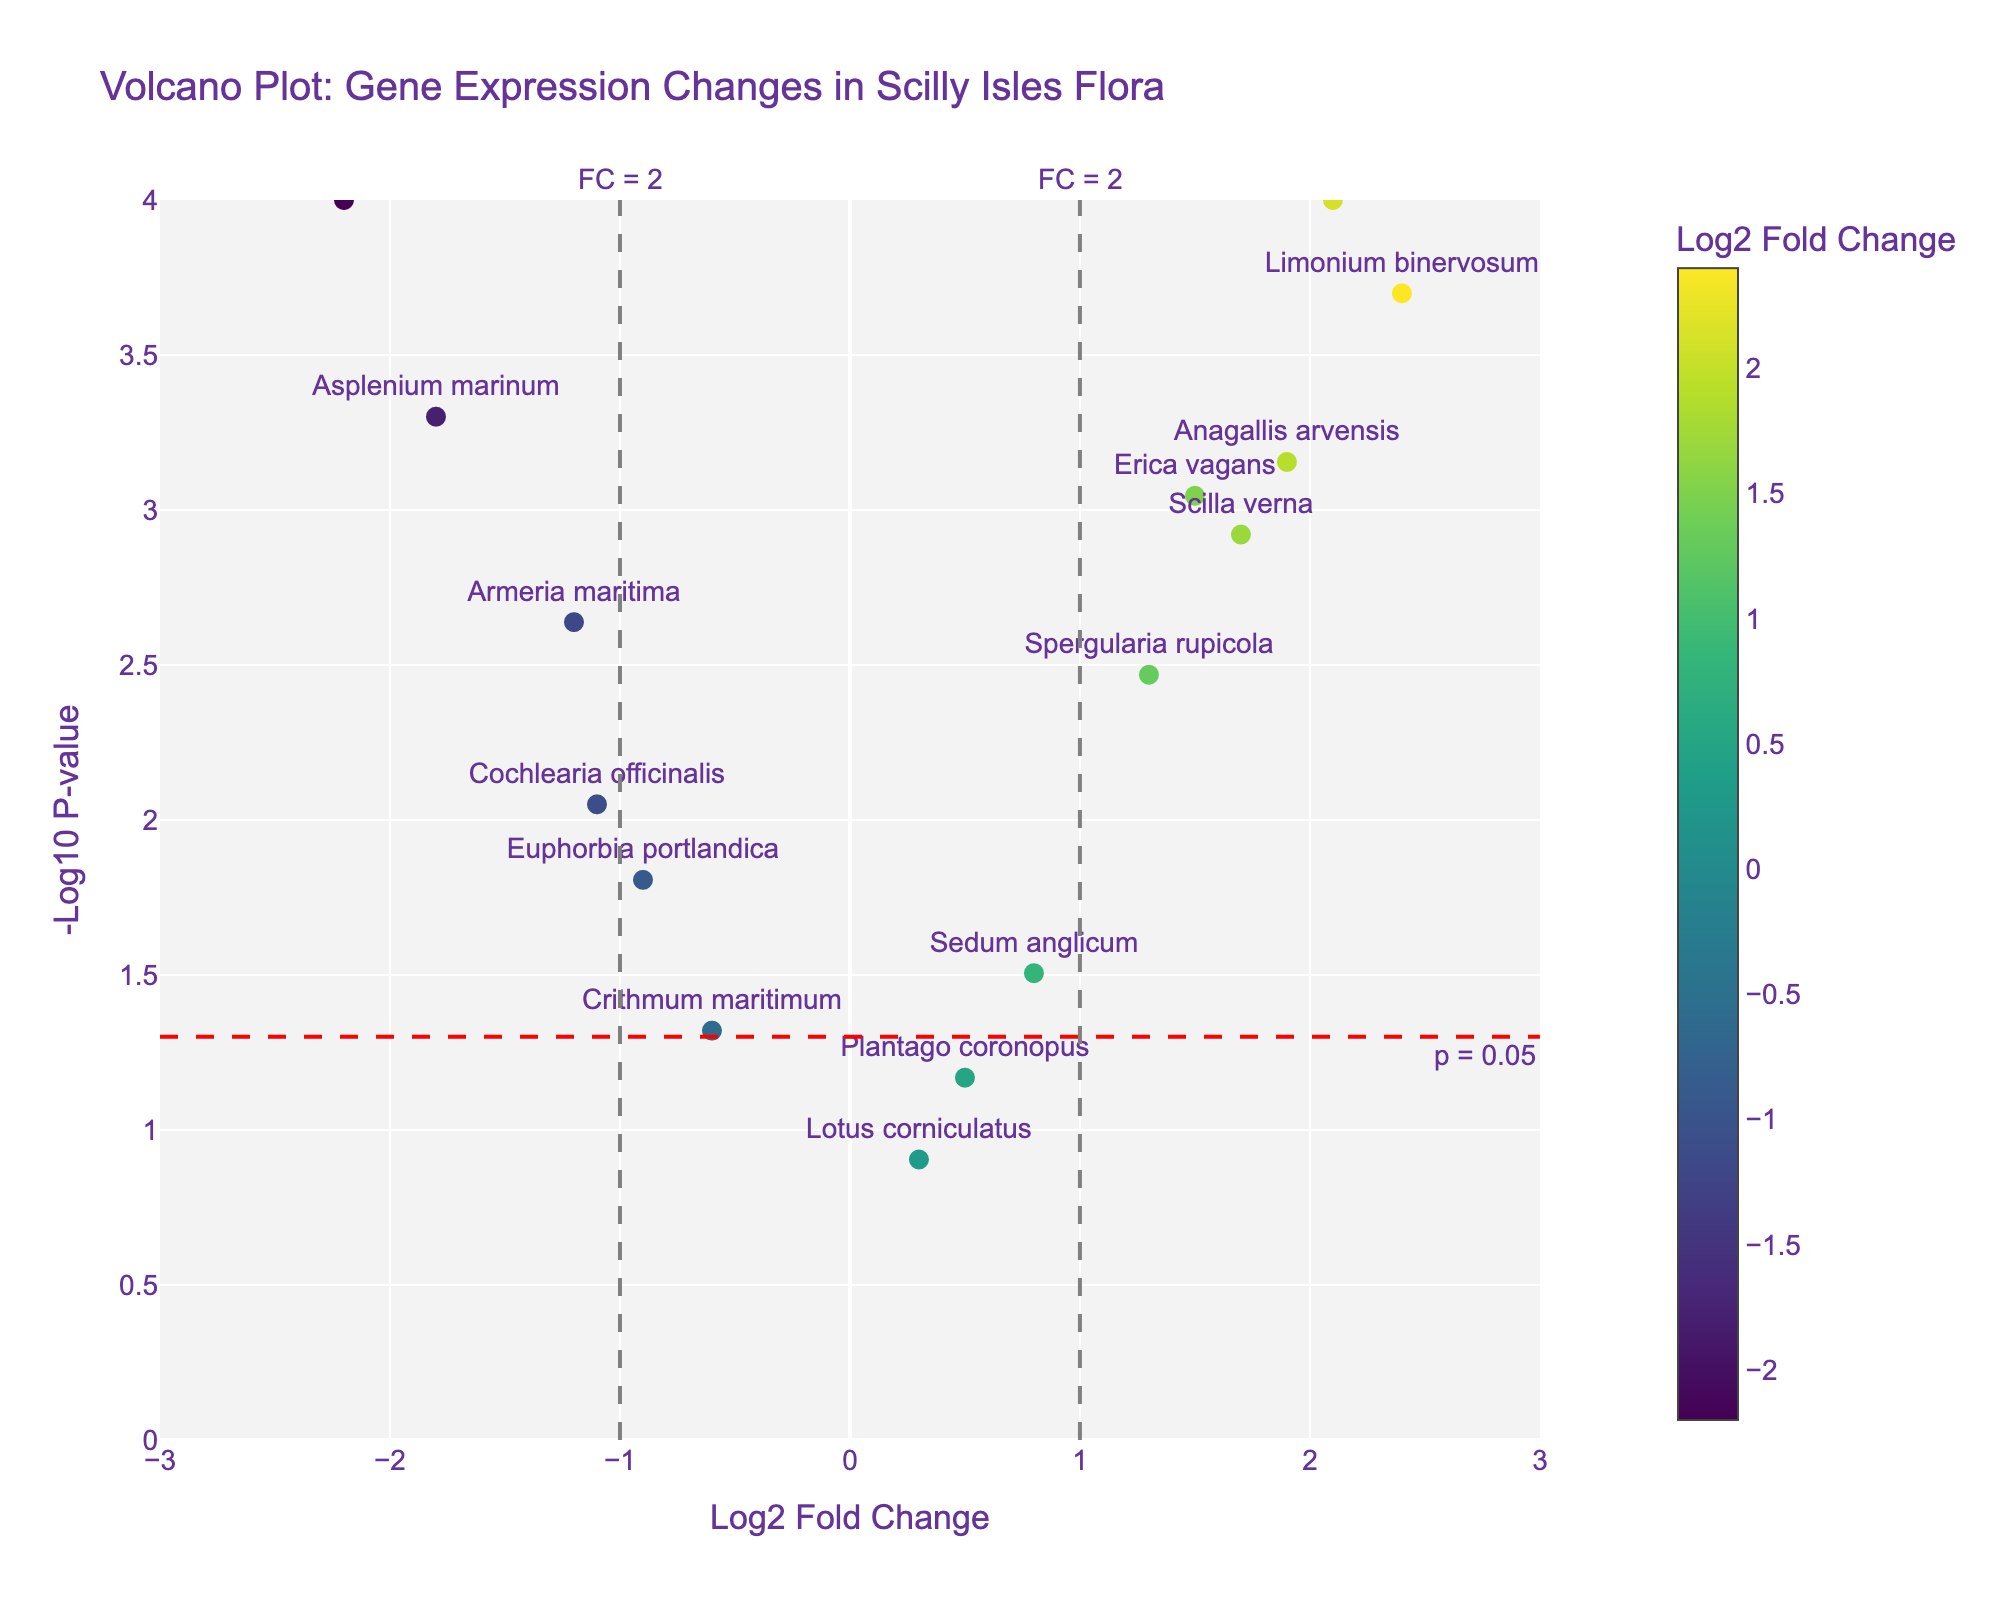What does the horizontal red dashed line in the plot represent? The horizontal red dashed line represents the -log10 transformed p-value threshold of 0.05. This line helps to determine the significance level of the p-values visually in the plot.
Answer: p = 0.05 Which gene has the highest log2 fold change? To determine the gene with the highest log2 fold change, look for the data point furthest to the right on the x-axis. This is the "Limonium binervosum" gene with a log2 fold change of 2.4.
Answer: Limonium binervosum How many genes have a p-value less than 0.05? The horizontal red dashed line at -log10(p-value) of 1.301 indicates the significance threshold for p-values less than 0.05. Count the number of data points above this line. There are 11 such points.
Answer: 11 Which gene shows the greatest decrease in expression due to climate change? The gene with the most negative log2 fold change value has the greatest decrease in expression. "Dactylorhiza praetermissa" has the lowest log2 fold change at -2.2.
Answer: Dactylorhiza praetermissa How many genes show a significant increase in expression (p-value < 0.05 and log2 fold change > 1)? First, find genes with p-values less than 0.05 (above the horizontal red dashed line). Then, within that subset, count the genes with log2 fold change values greater than 1. There are 5 such genes.
Answer: 5 Which gene has a log2 fold change of approximately 1.5? Check the x-axis for the log2 fold change of 1.5 and identify the corresponding gene name. This is "Erica vagans".
Answer: Erica vagans What is the p-value of "Asplenium marinum"? For "Asplenium marinum," the -log10(p-value) can be referred to or recalculated. The visual plot shows it's quite significant, positioning it at around -log10(0.0005) which confirms the p-value of 0.0005.
Answer: 0.0005 Which genes have a log2 fold change between -1 and 1 and a p-value less than 0.05? Identify the genes whose log2 fold change falls between -1 and 1 and are above the red dashed line. These genes are "Sedum anglicum," "Crithmum maritimum," "Cochlearia officinalis," and "Euphorbia portlandica."
Answer: Sedum anglicum, Crithmum maritimum, Cochlearia officinalis, Euphorbia portlandica 